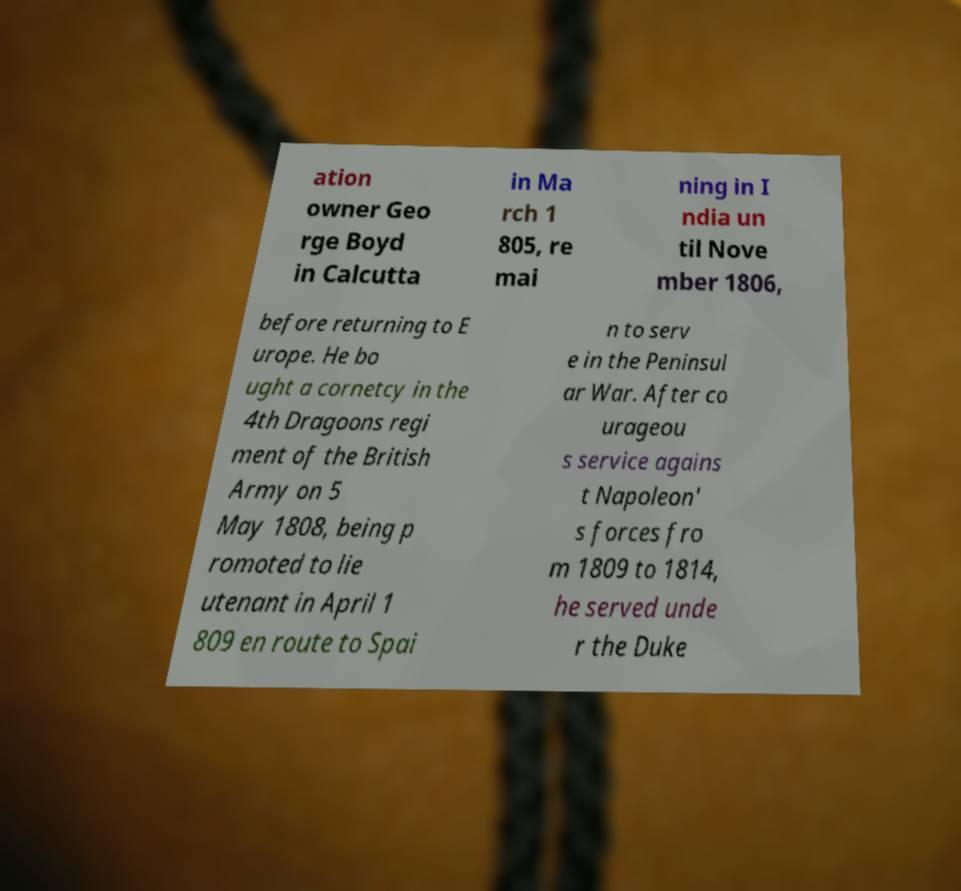For documentation purposes, I need the text within this image transcribed. Could you provide that? ation owner Geo rge Boyd in Calcutta in Ma rch 1 805, re mai ning in I ndia un til Nove mber 1806, before returning to E urope. He bo ught a cornetcy in the 4th Dragoons regi ment of the British Army on 5 May 1808, being p romoted to lie utenant in April 1 809 en route to Spai n to serv e in the Peninsul ar War. After co urageou s service agains t Napoleon' s forces fro m 1809 to 1814, he served unde r the Duke 